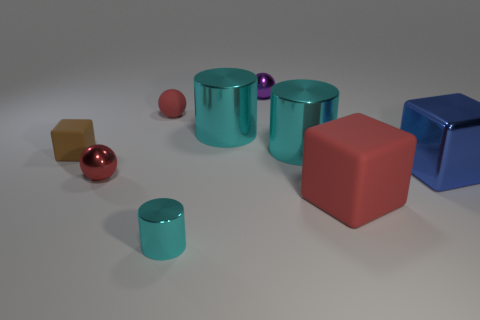Subtract all large cylinders. How many cylinders are left? 1 Subtract 2 cylinders. How many cylinders are left? 1 Subtract all purple balls. How many balls are left? 2 Subtract all spheres. How many objects are left? 6 Subtract 0 yellow cubes. How many objects are left? 9 Subtract all cyan spheres. Subtract all green cubes. How many spheres are left? 3 Subtract all cyan blocks. How many red balls are left? 2 Subtract all green objects. Subtract all matte objects. How many objects are left? 6 Add 4 large things. How many large things are left? 8 Add 1 small purple shiny things. How many small purple shiny things exist? 2 